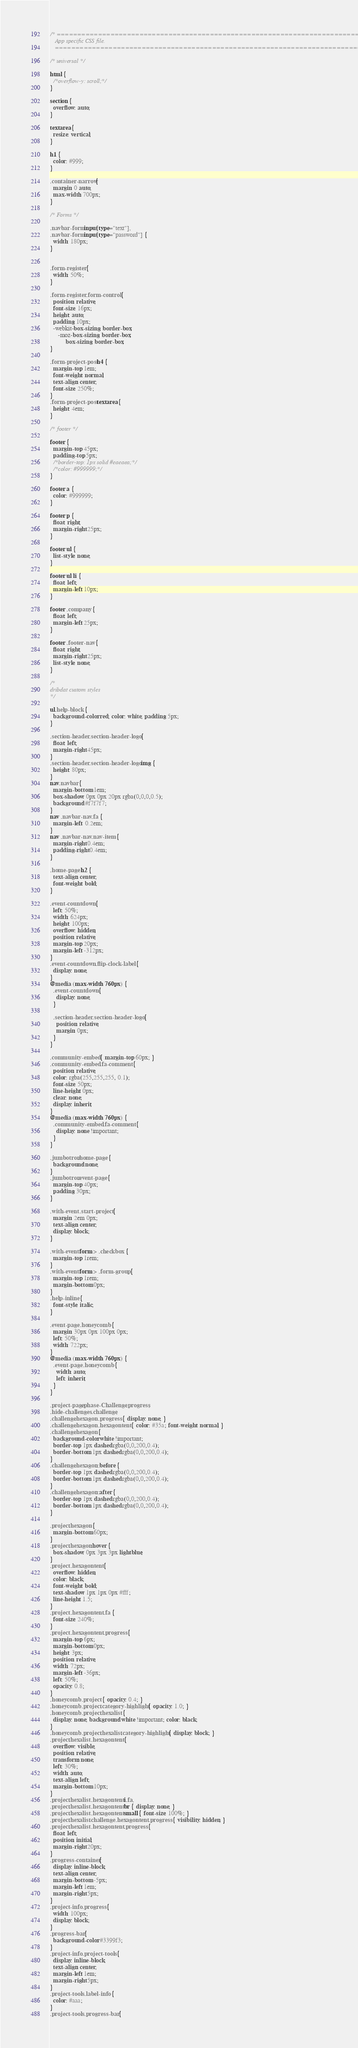Convert code to text. <code><loc_0><loc_0><loc_500><loc_500><_CSS_>/* =============================================================================
   App specific CSS file.
   ========================================================================== */

/* universal */

html {
  /*overflow-y: scroll;*/
}

section {
  overflow: auto;
}

textarea {
  resize: vertical;
}

h1 {
  color: #999;
}

.container-narrow {
  margin: 0 auto;
  max-width: 700px;
}

/* Forms */

.navbar-form input[type="text"],
.navbar-form input[type="password"] {
  width: 180px;
}


.form-register {
  width: 50%;
}

.form-register .form-control {
  position: relative;
  font-size: 16px;
  height: auto;
  padding: 10px;
  -webkit-box-sizing: border-box;
     -moz-box-sizing: border-box;
          box-sizing: border-box;
}

.form-project-post h4 {
  margin-top: 1em;
  font-weight: normal;
  text-align: center;
  font-size: 250%;
}
.form-project-post textarea {
  height: 4em;
}

/* footer */

footer {
  margin-top: 45px;
  padding-top: 5px;
  /*border-top: 1px solid #eaeaea;*/
  /*color: #999999;*/
}

footer a {
  color: #999999;
}

footer p {
  float: right;
  margin-right: 25px;
}

footer ul {
  list-style: none;
}

footer ul li {
  float: left;
  margin-left: 10px;
}

footer .company {
  float: left;
  margin-left: 25px;
}

footer .footer-nav {
  float: right;
  margin-right: 25px;
  list-style: none;
}

/*
dribdat custom styles
*/

ul.help-block {
  background-color: red; color: white; padding: 5px;
}

.section-header .section-header-logo {
  float: left;
  margin-right: 45px;
}
.section-header .section-header-logo img {
  height: 80px;
}
nav.navbar {
  margin-bottom: 1em;
  box-shadow: 0px 0px 20px rgba(0,0,0,0.5);
  background: #f7f7f7;
}
nav .navbar-nav .fa {
  margin-left:  0.2em;
}
nav .navbar-nav .nav-item {
  margin-right: 0.4em;
  padding-right: 0.4em;
}

.home-page h2 {
  text-align: center;
  font-weight: bold;
}

.event-countdown {
  left: 50%;
  width: 624px;
  height: 100px;
  overflow: hidden;
  position: relative;
  margin-top: 20px;
  margin-left: -312px;
}
.event-countdown .flip-clock-label {
  display: none;
}
@media (max-width: 760px) {
  .event-countdown {
    display: none;
  }

  .section-header .section-header-logo {
    position: relative;
    margin: 0px;
  }
}

.community-embed { margin-top: 60px; }
.community-embed .fa-comment {
  position: relative;
  color: rgba(255,255,255, 0.1);
  font-size: 50px;
  line-height: 0px;
  clear: none;
  display: inherit;
}
@media (max-width: 760px) {
  .community-embed .fa-comment {
    display: none !important;
  }
}

.jumbotron.home-page {
  background: none;
}
.jumbotron.event-page {
  margin-top: 40px;
  padding: 30px;
}

.with-event .start-project {
  margin: 2em 0px;
  text-align: center;
  display: block;
}

.with-event form > .checkbox {
  margin-top: 1rem;
}
.with-event form > .form-group {
  margin-top: 1rem;
  margin-bottom: 0px;
}
.help-inline {
  font-style: italic;
}

.event-page .honeycomb {
  margin: 30px 0px 100px 0px;
  left: 50%;
  width: 722px;
}
@media (max-width: 760px) {
  .event-page .honeycomb {
    width: auto;
    left: inherit;
  }
}

.project-page.phase-Challenge .progress,
.hide-challenges .challenge,
.challenge.hexagon .progress { display: none; }
.challenge.hexagon .hexagontent { color: #35a; font-weight: normal; }
.challenge.hexagon {
  background-color: white !important;
  border-top: 1px dashed rgba(0,0,200,0.4);
  border-bottom: 1px dashed rgba(0,0,200,0.4);
}
.challenge.hexagon::before {
  border-top: 1px dashed rgba(0,0,200,0.4);
  border-bottom: 1px dashed rgba(0,0,200,0.4);
}
.challenge.hexagon::after {
  border-top: 1px dashed rgba(0,0,200,0.4);
  border-bottom: 1px dashed rgba(0,0,200,0.4);
}

.project.hexagon {
  margin-bottom: 60px;
}
.project.hexagon:hover {
  box-shadow: 0px 3px 3px lightblue;
}
.project .hexagontent {
  overflow: hidden;
  color: black;
  font-weight: bold;
  text-shadow: 1px 1px 0px #fff;
  line-height: 1.5;
}
.project .hexagontent .fa {
  font-size: 240%;
}
.project .hexagontent .progress {
  margin-top: 6px;
  margin-bottom: 0px;
  height: 3px;
  position: relative;
  width: 72px;
  margin-left: -36px;
  left: 50%;
  opacity: 0.8;
}
.honeycomb .project { opacity: 0.4; }
.honeycomb .project.category-highlight { opacity: 1.0; }
.honeycomb .project.hexalist {
  display: none; background: white !important; color: black;
}
.honeycomb .project.hexalist.category-highlight { display: block; }
.project.hexalist .hexagontent {
  overflow: visible;
  position: relative;
  transform: none;
  left: 30%;
  width: auto;
  text-align: left;
  margin-bottom: 10px;
}
.project.hexalist .hexagontent i.fa,
.project.hexalist .hexagontent br { display: none; }
.project.hexalist .hexagontent small { font-size: 100%; }
.project.hexalist.challenge .hexagontent .progress { visibility: hidden; }
.project.hexalist .hexagontent .progress {
  float: left;
  position: initial;
  margin-right: 20px;
}
.progress-container {
  display: inline-block;
  text-align: center;
  margin-bottom: -5px;
  margin-left: 1em;
  margin-right: 5px;
}
.project-info .progress {
  width: 100px;
  display: block;
}
.progress-bar {
  background-color: #3399f3;
}
.project-info .project-tools {
  display: inline-block;
  text-align: center;
  margin-left: 1em;
  margin-right: 5px;
}
.project-tools .label-info {
  color: #aaa;
}
.project-tools .progress-bar {</code> 